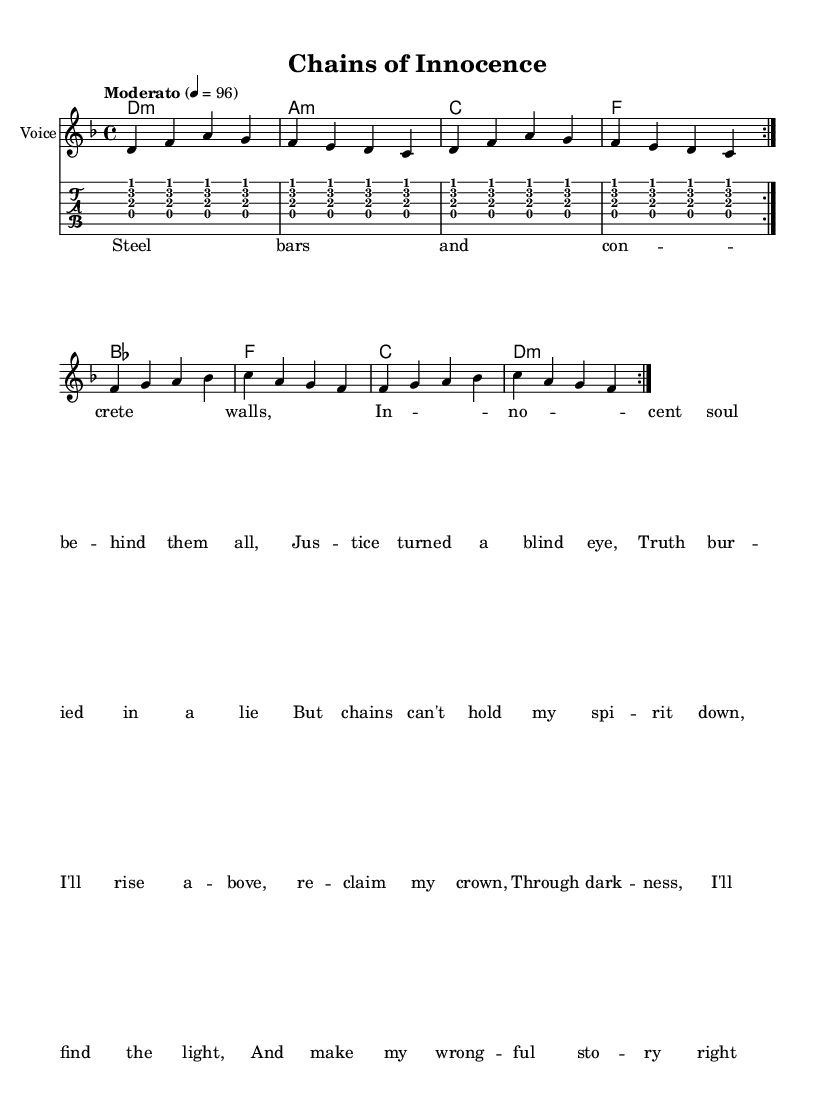What is the key signature of this music? The key signature is indicated by the flattened note(s) at the beginning of the staff. In this case, it shows a B flat, indicating that the key is D minor which traditionally has one flat (B flat).
Answer: D minor What is the time signature of this music? The time signature is found immediately after the key signature and shows the rhythmic structure. Here, it is indicated as 4/4, meaning four beats per measure.
Answer: 4/4 What is the tempo marking of this piece? The tempo marking is stated both in words and in a specific tempo value. It indicates the speed of the piece; here it is marked as "Moderato", with a metronome marking of 96 beats per minute.
Answer: Moderato Which instrument is primarily indicated for this score? The name of the instrument is specified at the beginning of the staff and it shows what is intended to play. In this case, it is labeled as "Voice."
Answer: Voice How many times is the verse repeated in this song? The repetition is indicated by the "repeat" instructions found in the score. The notation shows that the verse section is repeated two times before moving on to the chorus.
Answer: 2 What is the last line of the lyrics before the chorus? The lyrics are provided below the staff, and we look towards the end of the verse for the last line before the chorus begins. The last line of the verse is "Truth bur -- ied in a lie."
Answer: Truth bur -- ied in a lie What chord follows the "innocent soul behind them all" lyric in the chorus? To find the chord that accompanies a specific lyric, we look at the chord names written above the lyrics closely aligned to them. The chord follows the corresponding syllable in the phrase. This phrase is followed by an F chord in the music sheet.
Answer: F 